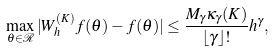Convert formula to latex. <formula><loc_0><loc_0><loc_500><loc_500>\max _ { \theta \in \mathcal { R } } | W _ { h } ^ { ( K ) } f ( \theta ) - f ( \theta ) | \leq \frac { M _ { \gamma } \kappa _ { \gamma } ( K ) } { \lfloor \gamma \rfloor ! } h ^ { \gamma } ,</formula> 